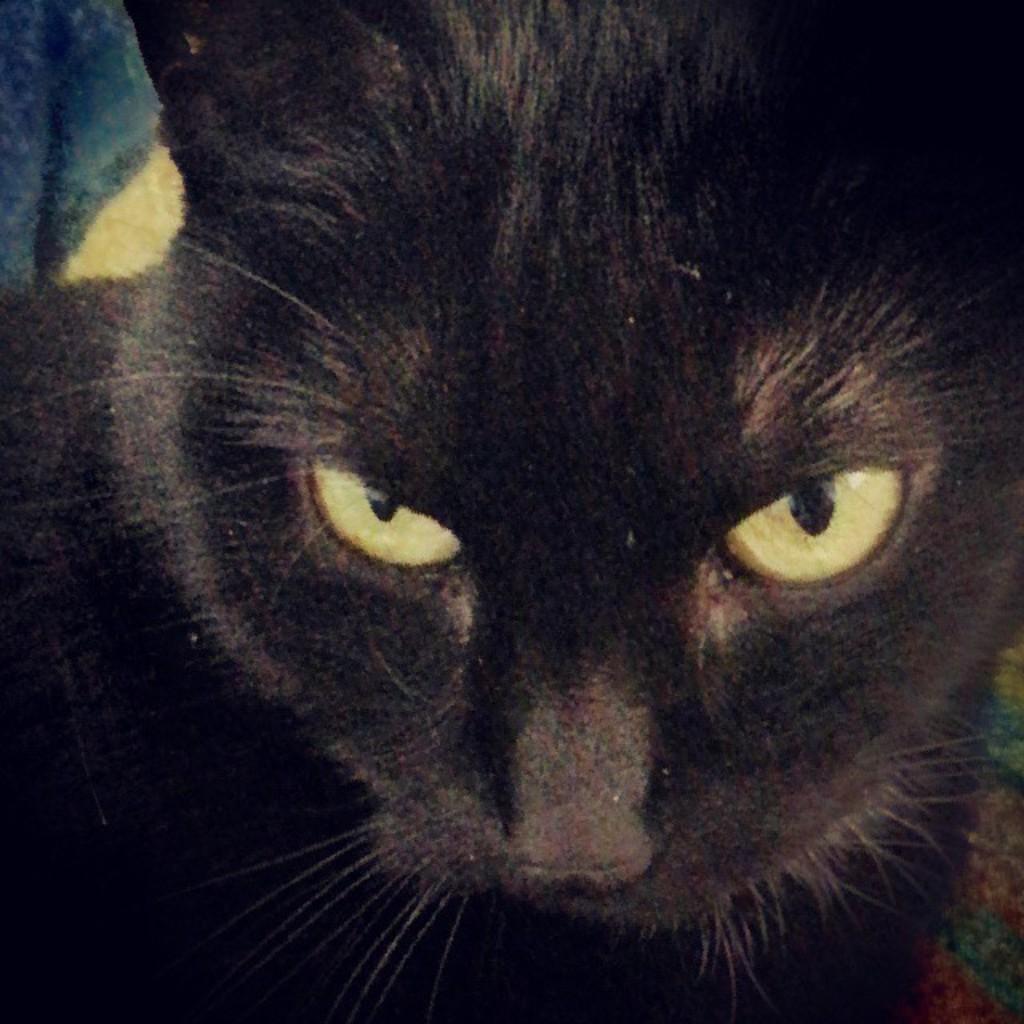Can you describe this image briefly? In the image we can see a cat, black in color. 